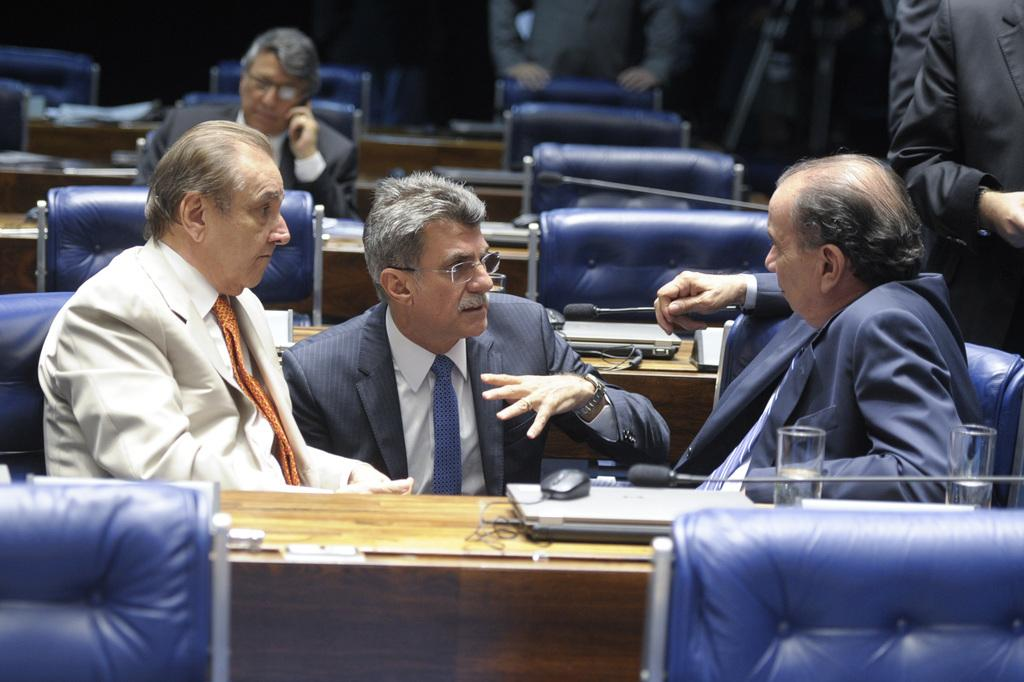How many people are in the image? There are people in the image, but the exact number is not specified. What type of furniture is present in the image? Chairs and tables are visible in the image. What items can be seen on the tables? There are glasses, laptops, and a mouse on the tables. Are the people in the image whispering to each other? The image does not provide any information about the people's actions or conversations, so it cannot be determined if they are whispering or not. 